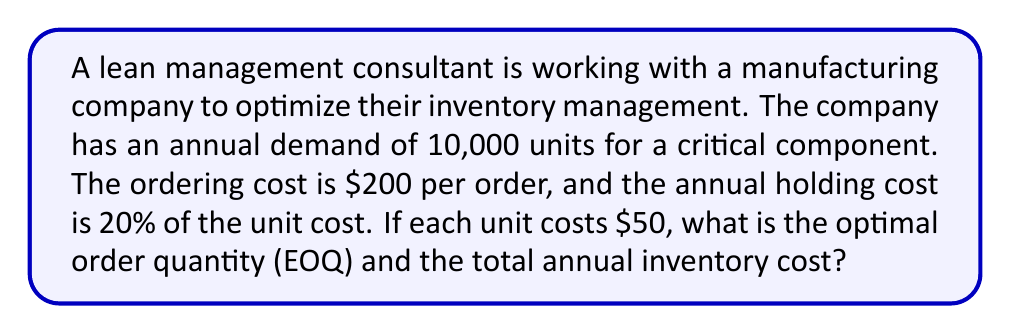Teach me how to tackle this problem. To solve this problem, we'll use the Economic Order Quantity (EOQ) model. The EOQ model helps determine the optimal order quantity that minimizes total inventory costs, balancing ordering costs and holding costs.

The EOQ formula is:

$$EOQ = \sqrt{\frac{2DS}{H}}$$

Where:
$D$ = Annual demand
$S$ = Ordering cost per order
$H$ = Annual holding cost per unit

Given:
$D = 10,000$ units
$S = \$200$ per order
$H = 20\% \times \$50 = \$10$ per unit per year

Step 1: Calculate the EOQ
$$EOQ = \sqrt{\frac{2 \times 10,000 \times 200}{10}} = \sqrt{400,000} = 632.46$$

Round to the nearest whole number: 632 units

Step 2: Calculate the number of orders per year
$$\text{Number of orders} = \frac{\text{Annual demand}}{\text{EOQ}} = \frac{10,000}{632} \approx 15.82$$

Step 3: Calculate the total annual cost
Total annual cost = Annual ordering cost + Annual holding cost

Annual ordering cost = (Number of orders) × (Cost per order)
$$\text{Annual ordering cost} = 15.82 \times \$200 = \$3,164$$

Annual holding cost = (Average inventory) × (Annual holding cost per unit)
$$\text{Annual holding cost} = \frac{632}{2} \times \$10 = \$3,160$$

Total annual cost = $3,164 + $3,160 = $6,324
Answer: The optimal order quantity (EOQ) is 632 units, and the total annual inventory cost is $6,324. 